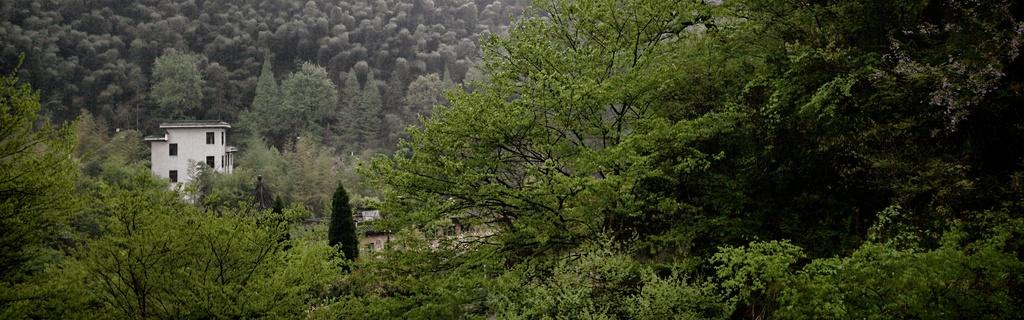What is located in the foreground of the image? There are trees in the foreground of the image. What structure can be seen on the left side of the image? There is a building on the left side of the image. What is visible in the background of the image? There are trees in the background of the image. How many girls are standing on the hill in the image? There are no girls or hills present in the image. What type of foot is visible on the hill in the image? There is no foot or hill present in the image. 